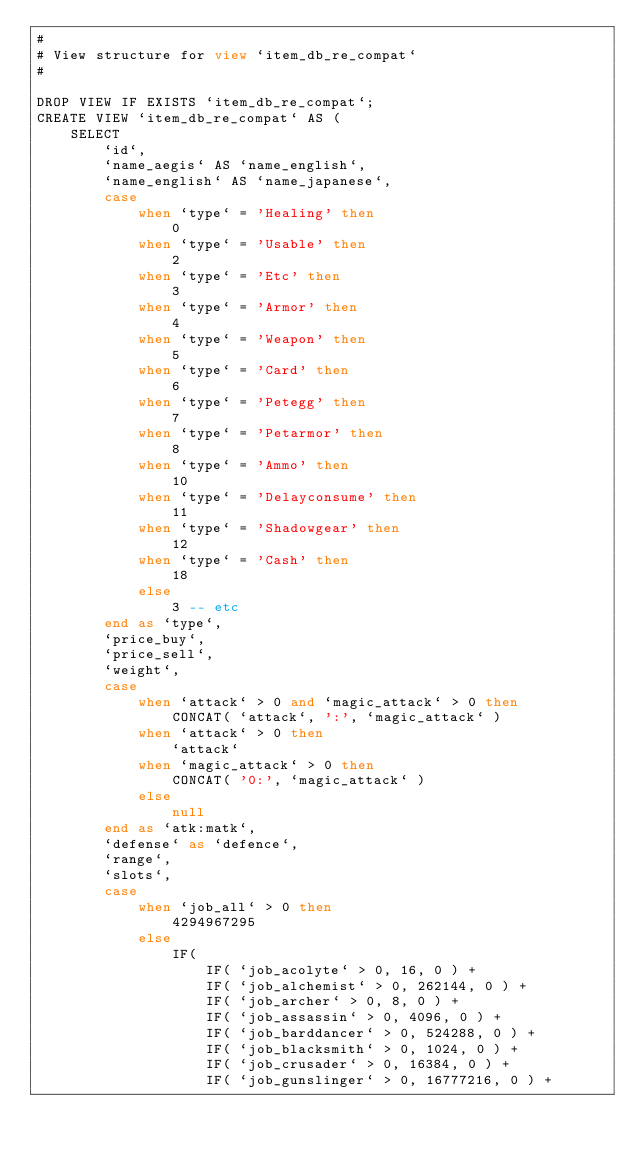Convert code to text. <code><loc_0><loc_0><loc_500><loc_500><_SQL_>#
# View structure for view `item_db_re_compat`
#

DROP VIEW IF EXISTS `item_db_re_compat`;
CREATE VIEW `item_db_re_compat` AS (
	SELECT
		`id`,
		`name_aegis` AS `name_english`,
		`name_english` AS `name_japanese`,
		case
			when `type` = 'Healing' then
				0
			when `type` = 'Usable' then
				2
			when `type` = 'Etc' then
				3
			when `type` = 'Armor' then
				4
			when `type` = 'Weapon' then
				5
			when `type` = 'Card' then
				6
			when `type` = 'Petegg' then
				7
			when `type` = 'Petarmor' then
				8
			when `type` = 'Ammo' then
				10
			when `type` = 'Delayconsume' then
				11
			when `type` = 'Shadowgear' then
				12
			when `type` = 'Cash' then
				18
			else
				3 -- etc
		end as `type`,
		`price_buy`,
		`price_sell`,
		`weight`,
		case
			when `attack` > 0 and `magic_attack` > 0 then
				CONCAT( `attack`, ':', `magic_attack` )
			when `attack` > 0 then
				`attack`
			when `magic_attack` > 0 then
				CONCAT( '0:', `magic_attack` )
			else
				null
		end as `atk:matk`,
		`defense` as `defence`,
		`range`,
		`slots`,
		case
			when `job_all` > 0 then
				4294967295
			else
				IF(
					IF( `job_acolyte` > 0, 16, 0 ) +
					IF( `job_alchemist` > 0, 262144, 0 ) +
					IF( `job_archer` > 0, 8, 0 ) +
					IF( `job_assassin` > 0, 4096, 0 ) +
					IF( `job_barddancer` > 0, 524288, 0 ) +
					IF( `job_blacksmith` > 0, 1024, 0 ) +
					IF( `job_crusader` > 0, 16384, 0 ) +
					IF( `job_gunslinger` > 0, 16777216, 0 ) +</code> 